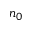<formula> <loc_0><loc_0><loc_500><loc_500>n _ { 0 }</formula> 